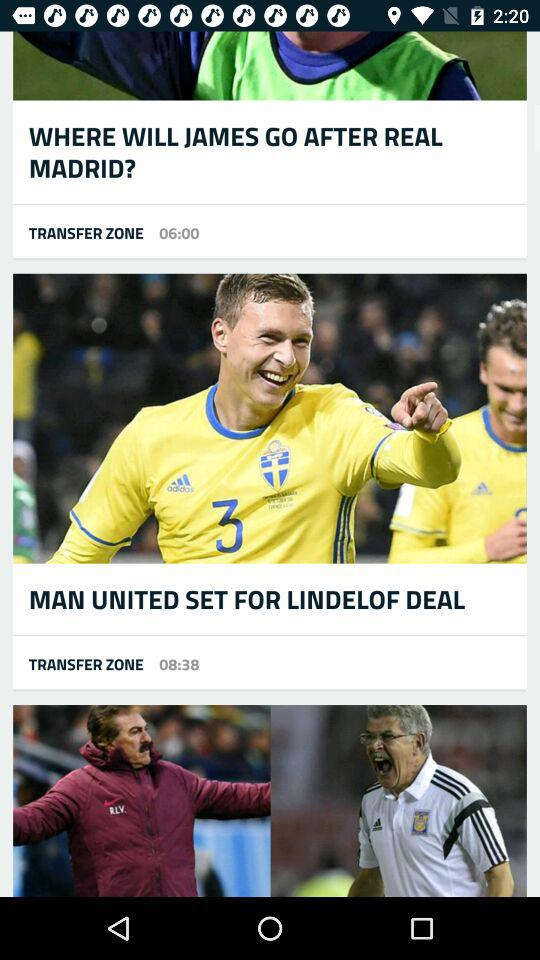At what time was the news "LINDELOF DEAL" posted by "TRANSFER ZONE"? The news "LINDELOF DEAL" was posted by "TRANSFER ZONE" at 08:38. 